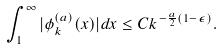<formula> <loc_0><loc_0><loc_500><loc_500>\int _ { 1 } ^ { \infty } | \phi _ { k } ^ { ( a ) } ( x ) | d x \leq C k ^ { - \frac { a } { 2 } ( 1 - \epsilon ) } .</formula> 